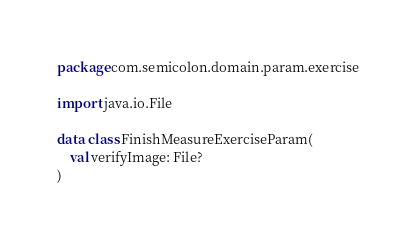<code> <loc_0><loc_0><loc_500><loc_500><_Kotlin_>package com.semicolon.domain.param.exercise

import java.io.File

data class FinishMeasureExerciseParam(
    val verifyImage: File?
)</code> 